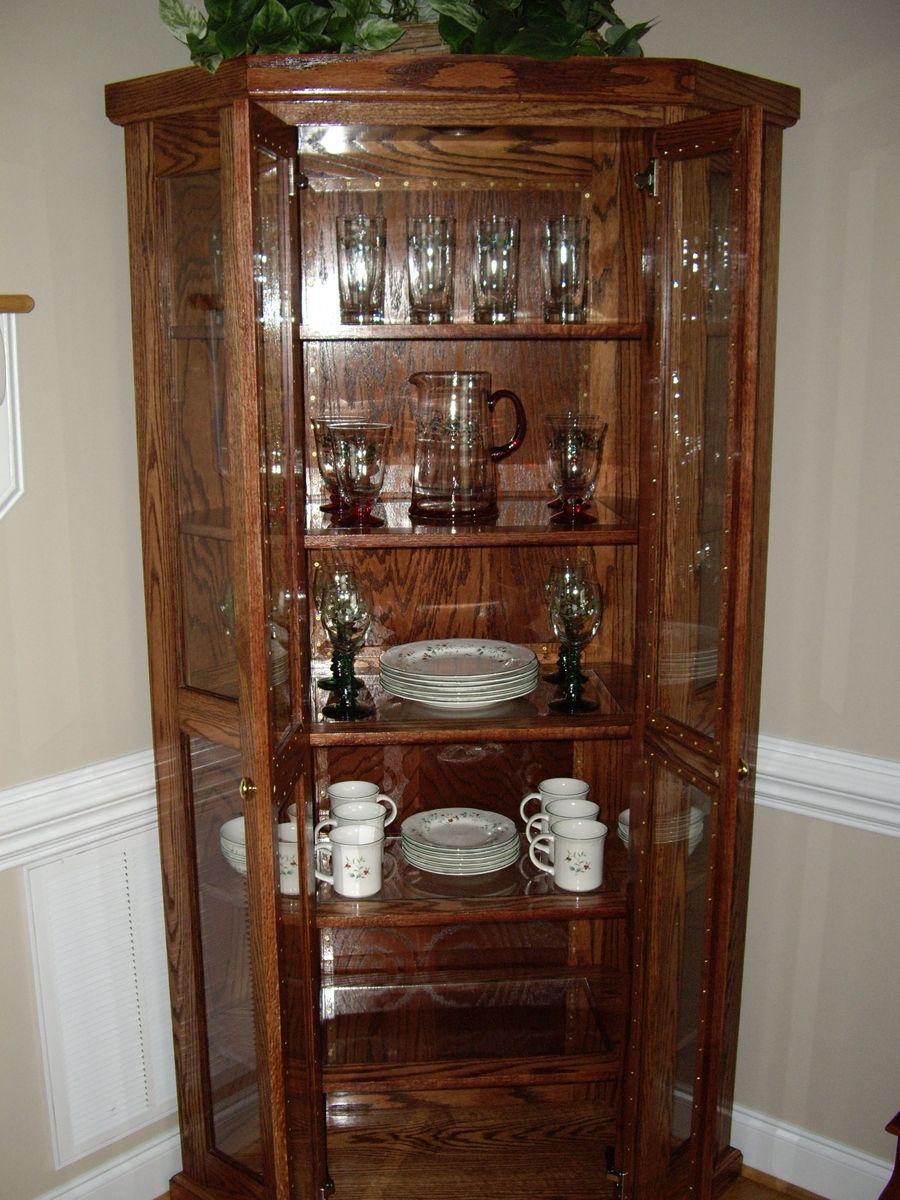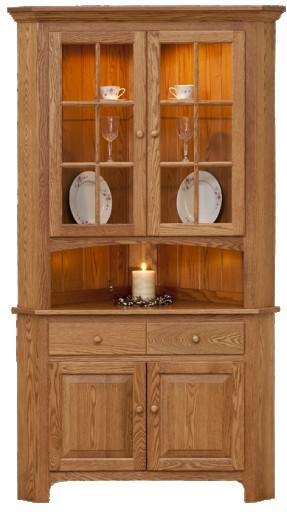The first image is the image on the left, the second image is the image on the right. Assess this claim about the two images: "a picture frame is visible on the right image.". Correct or not? Answer yes or no. No. 